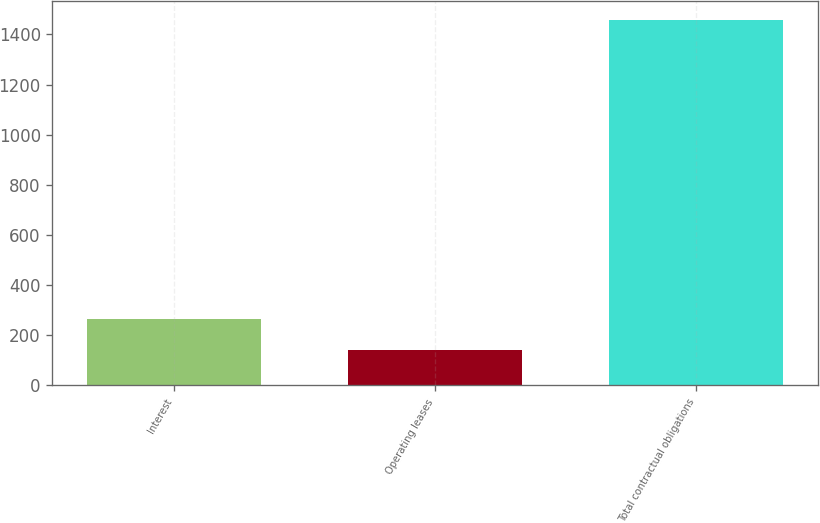Convert chart to OTSL. <chart><loc_0><loc_0><loc_500><loc_500><bar_chart><fcel>Interest<fcel>Operating leases<fcel>Total contractual obligations<nl><fcel>263.8<fcel>142<fcel>1458.8<nl></chart> 